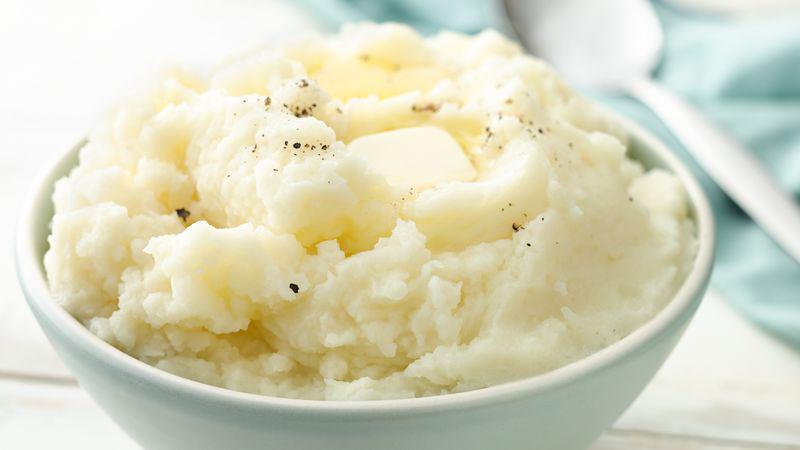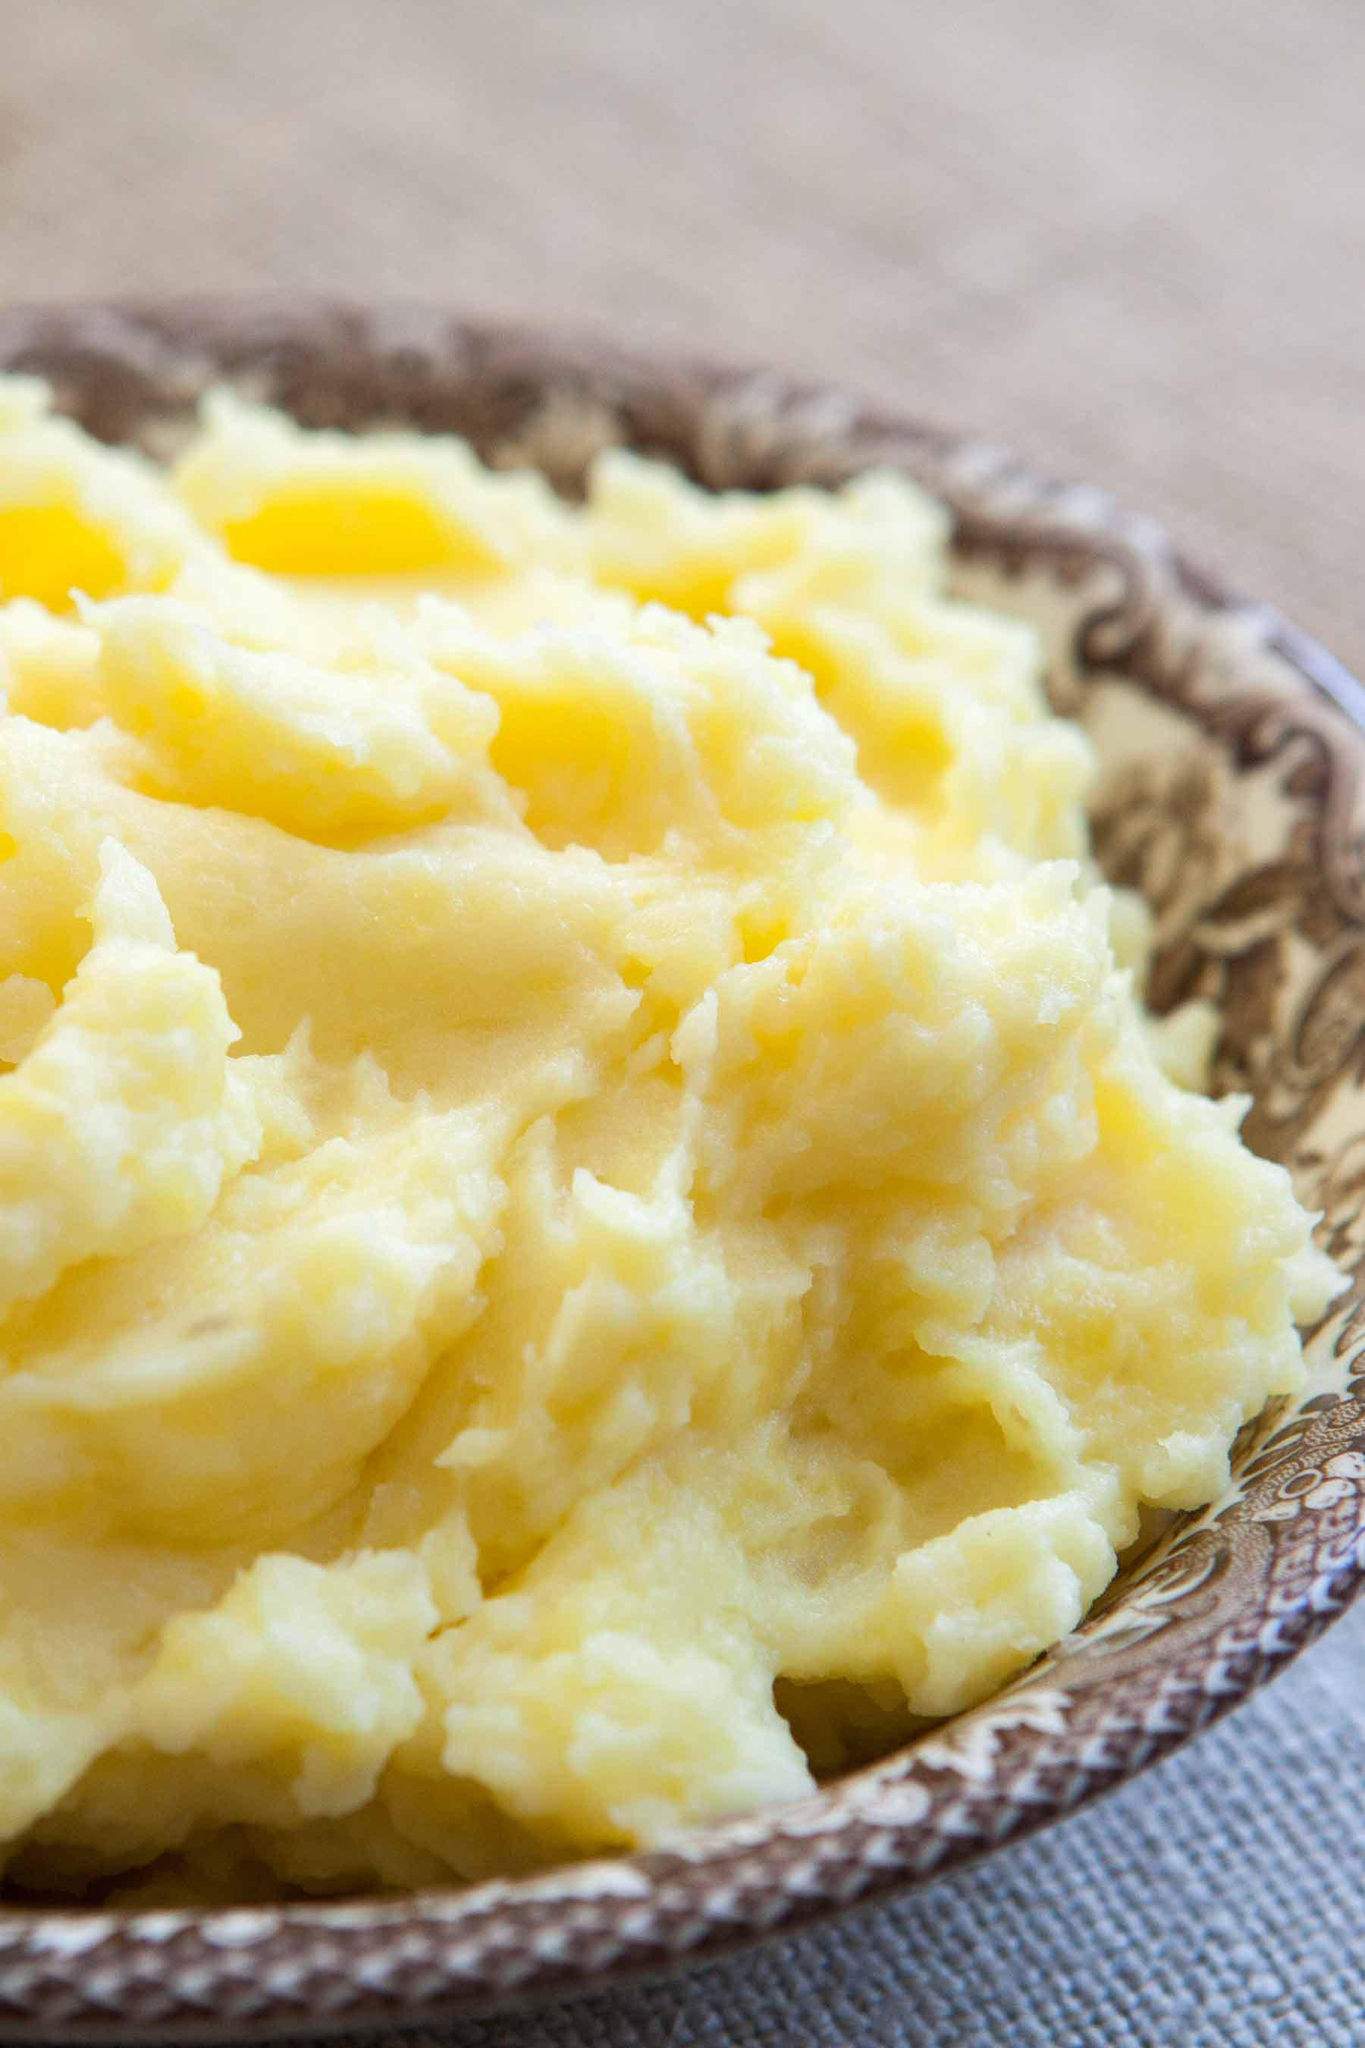The first image is the image on the left, the second image is the image on the right. Assess this claim about the two images: "One image has an eating utensil.". Correct or not? Answer yes or no. Yes. The first image is the image on the left, the second image is the image on the right. For the images displayed, is the sentence "A handle is sticking out of the round bowl of potatoes in the right image." factually correct? Answer yes or no. No. 